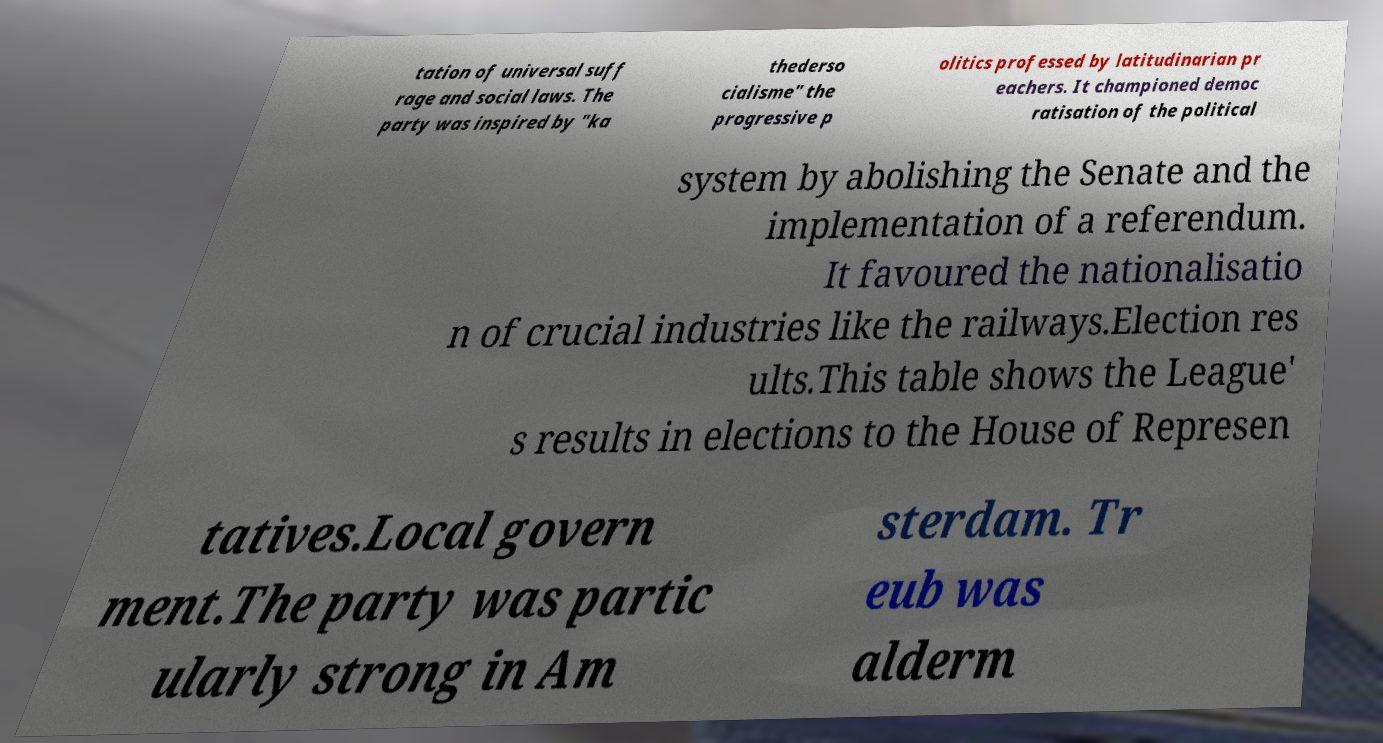Please read and relay the text visible in this image. What does it say? tation of universal suff rage and social laws. The party was inspired by "ka thederso cialisme" the progressive p olitics professed by latitudinarian pr eachers. It championed democ ratisation of the political system by abolishing the Senate and the implementation of a referendum. It favoured the nationalisatio n of crucial industries like the railways.Election res ults.This table shows the League' s results in elections to the House of Represen tatives.Local govern ment.The party was partic ularly strong in Am sterdam. Tr eub was alderm 